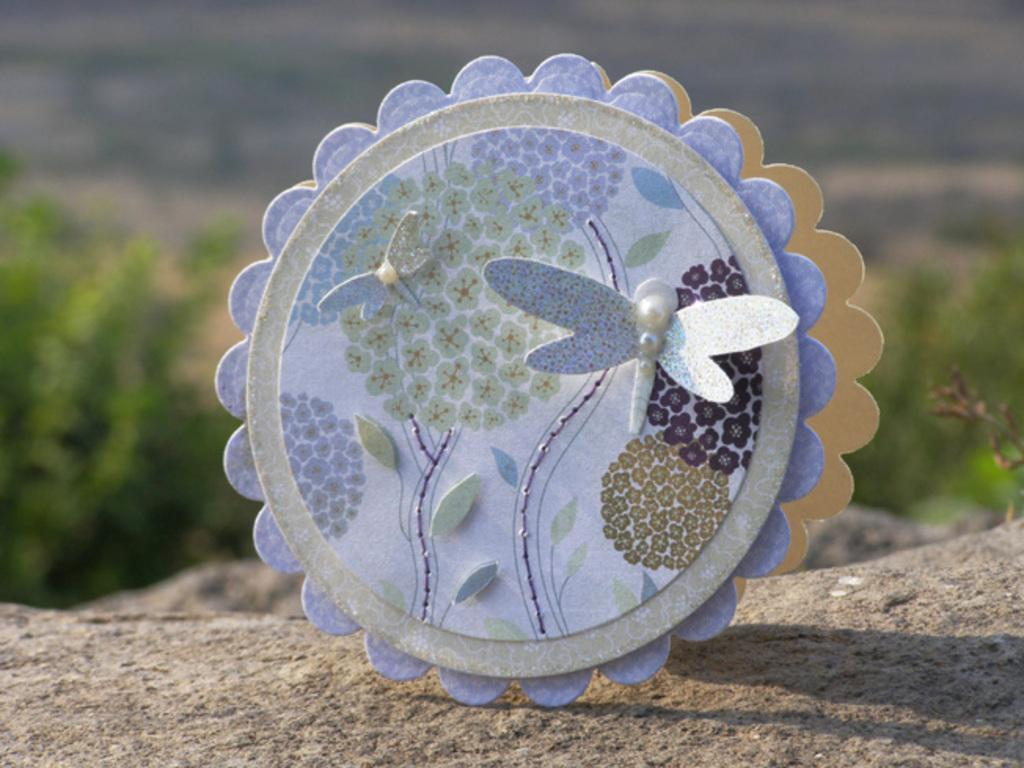What can be described as the main subject in the image? There is a colorful object in the image. Can you provide any details about the background of the image? The background of the image is blurry. What type of loss is the stranger experiencing in the image? There is no stranger or loss present in the image; it only features a colorful object and a blurry background. 